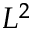<formula> <loc_0><loc_0><loc_500><loc_500>L ^ { 2 }</formula> 